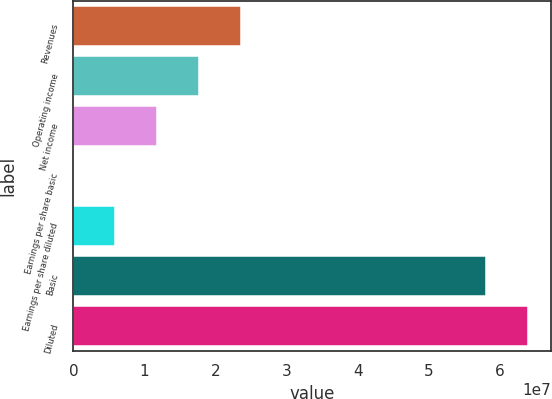Convert chart to OTSL. <chart><loc_0><loc_0><loc_500><loc_500><bar_chart><fcel>Revenues<fcel>Operating income<fcel>Net income<fcel>Earnings per share basic<fcel>Earnings per share diluted<fcel>Basic<fcel>Diluted<nl><fcel>2.35401e+07<fcel>1.76551e+07<fcel>1.17701e+07<fcel>0.22<fcel>5.88503e+06<fcel>5.81001e+07<fcel>6.39852e+07<nl></chart> 